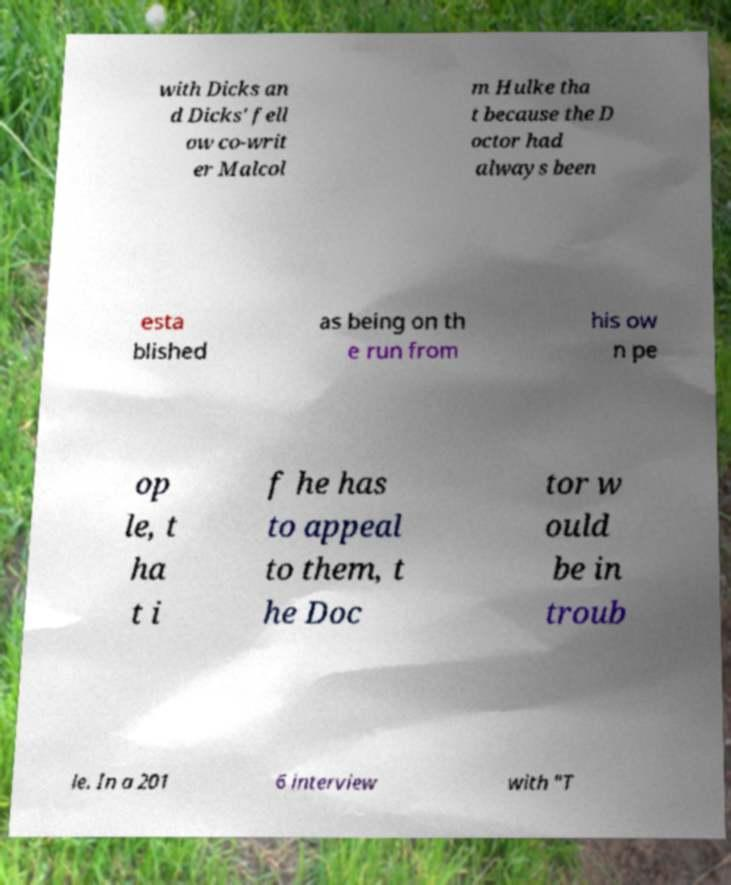I need the written content from this picture converted into text. Can you do that? with Dicks an d Dicks' fell ow co-writ er Malcol m Hulke tha t because the D octor had always been esta blished as being on th e run from his ow n pe op le, t ha t i f he has to appeal to them, t he Doc tor w ould be in troub le. In a 201 6 interview with "T 